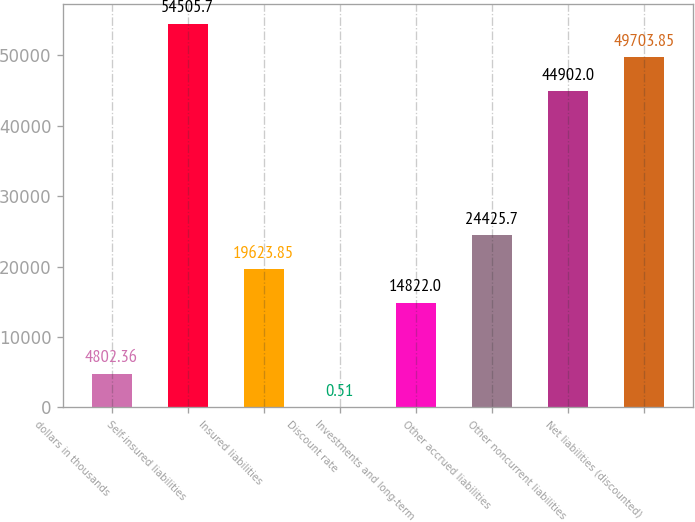Convert chart to OTSL. <chart><loc_0><loc_0><loc_500><loc_500><bar_chart><fcel>dollars in thousands<fcel>Self-insured liabilities<fcel>Insured liabilities<fcel>Discount rate<fcel>Investments and long-term<fcel>Other accrued liabilities<fcel>Other noncurrent liabilities<fcel>Net liabilities (discounted)<nl><fcel>4802.36<fcel>54505.7<fcel>19623.8<fcel>0.51<fcel>14822<fcel>24425.7<fcel>44902<fcel>49703.8<nl></chart> 